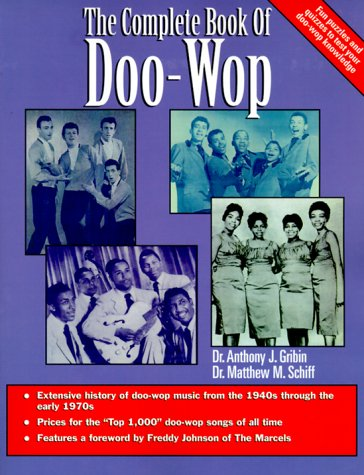Who is the author of this book? The book, titled 'The Complete Book of Doo-Wop Rhythm and Blues', lists Dr. Anthony Gribin as the author, representing his significant contribution to documenting the history of this music genre. 